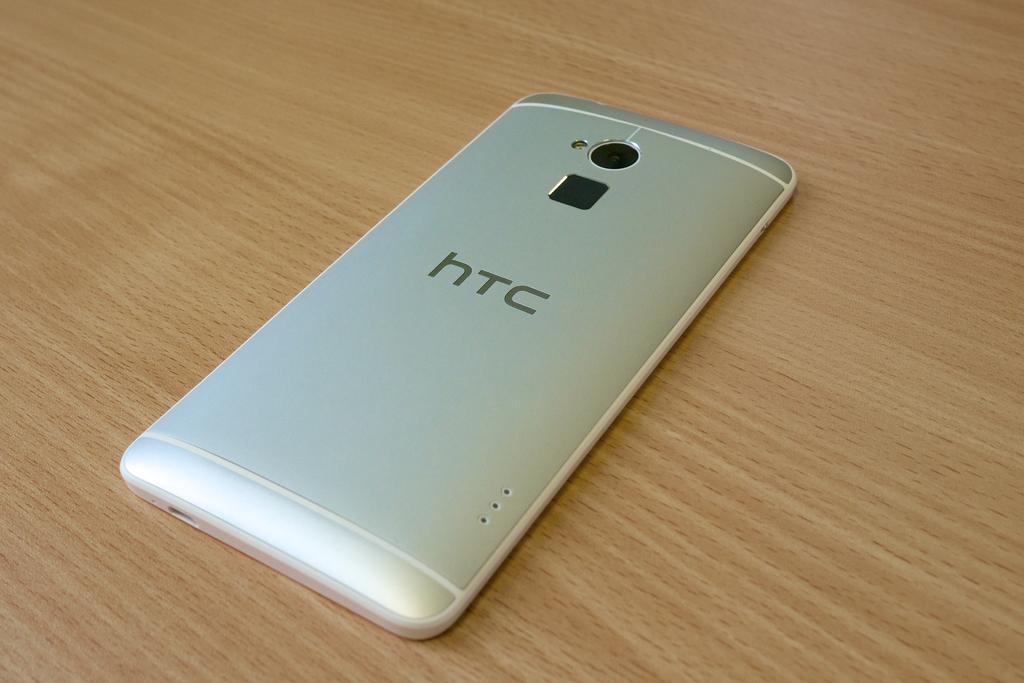What brand of phone is this?
Ensure brevity in your answer.  Htc. 